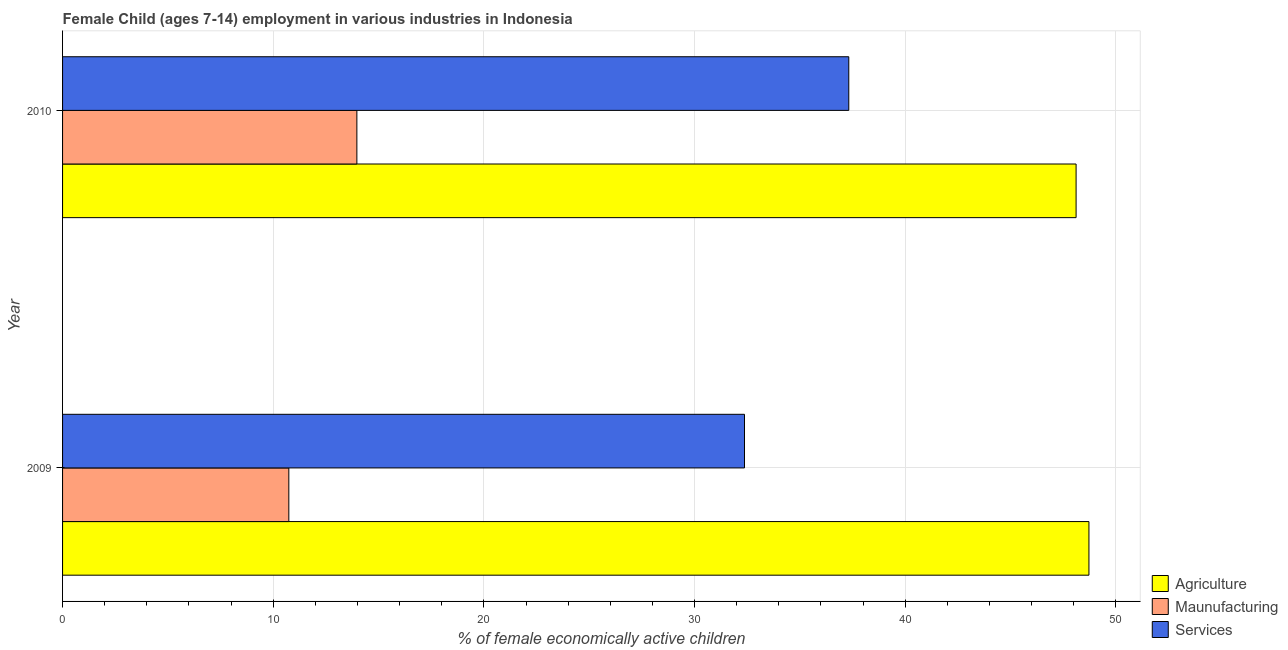How many groups of bars are there?
Offer a very short reply. 2. Are the number of bars per tick equal to the number of legend labels?
Make the answer very short. Yes. Are the number of bars on each tick of the Y-axis equal?
Your answer should be very brief. Yes. How many bars are there on the 2nd tick from the top?
Provide a succinct answer. 3. How many bars are there on the 1st tick from the bottom?
Ensure brevity in your answer.  3. What is the label of the 2nd group of bars from the top?
Your response must be concise. 2009. What is the percentage of economically active children in agriculture in 2009?
Make the answer very short. 48.72. Across all years, what is the maximum percentage of economically active children in manufacturing?
Your answer should be compact. 13.97. Across all years, what is the minimum percentage of economically active children in agriculture?
Your answer should be compact. 48.11. In which year was the percentage of economically active children in agriculture maximum?
Offer a very short reply. 2009. What is the total percentage of economically active children in manufacturing in the graph?
Offer a terse response. 24.71. What is the difference between the percentage of economically active children in manufacturing in 2009 and that in 2010?
Ensure brevity in your answer.  -3.23. What is the difference between the percentage of economically active children in manufacturing in 2010 and the percentage of economically active children in services in 2009?
Ensure brevity in your answer.  -18.4. What is the average percentage of economically active children in services per year?
Offer a very short reply. 34.84. In the year 2010, what is the difference between the percentage of economically active children in services and percentage of economically active children in manufacturing?
Give a very brief answer. 23.35. What is the ratio of the percentage of economically active children in manufacturing in 2009 to that in 2010?
Keep it short and to the point. 0.77. Is the percentage of economically active children in services in 2009 less than that in 2010?
Keep it short and to the point. Yes. Is the difference between the percentage of economically active children in agriculture in 2009 and 2010 greater than the difference between the percentage of economically active children in manufacturing in 2009 and 2010?
Your answer should be compact. Yes. In how many years, is the percentage of economically active children in services greater than the average percentage of economically active children in services taken over all years?
Your response must be concise. 1. What does the 1st bar from the top in 2009 represents?
Provide a short and direct response. Services. What does the 2nd bar from the bottom in 2009 represents?
Offer a very short reply. Maunufacturing. How many bars are there?
Offer a very short reply. 6. Are all the bars in the graph horizontal?
Offer a terse response. Yes. How many years are there in the graph?
Offer a terse response. 2. Does the graph contain any zero values?
Your response must be concise. No. How are the legend labels stacked?
Ensure brevity in your answer.  Vertical. What is the title of the graph?
Make the answer very short. Female Child (ages 7-14) employment in various industries in Indonesia. Does "Infant(male)" appear as one of the legend labels in the graph?
Offer a very short reply. No. What is the label or title of the X-axis?
Your answer should be compact. % of female economically active children. What is the label or title of the Y-axis?
Make the answer very short. Year. What is the % of female economically active children of Agriculture in 2009?
Give a very brief answer. 48.72. What is the % of female economically active children in Maunufacturing in 2009?
Provide a succinct answer. 10.74. What is the % of female economically active children of Services in 2009?
Offer a terse response. 32.37. What is the % of female economically active children of Agriculture in 2010?
Make the answer very short. 48.11. What is the % of female economically active children in Maunufacturing in 2010?
Your answer should be very brief. 13.97. What is the % of female economically active children of Services in 2010?
Provide a short and direct response. 37.32. Across all years, what is the maximum % of female economically active children of Agriculture?
Provide a short and direct response. 48.72. Across all years, what is the maximum % of female economically active children of Maunufacturing?
Offer a very short reply. 13.97. Across all years, what is the maximum % of female economically active children of Services?
Make the answer very short. 37.32. Across all years, what is the minimum % of female economically active children of Agriculture?
Your answer should be compact. 48.11. Across all years, what is the minimum % of female economically active children of Maunufacturing?
Make the answer very short. 10.74. Across all years, what is the minimum % of female economically active children in Services?
Offer a terse response. 32.37. What is the total % of female economically active children in Agriculture in the graph?
Ensure brevity in your answer.  96.83. What is the total % of female economically active children in Maunufacturing in the graph?
Ensure brevity in your answer.  24.71. What is the total % of female economically active children in Services in the graph?
Keep it short and to the point. 69.69. What is the difference between the % of female economically active children of Agriculture in 2009 and that in 2010?
Give a very brief answer. 0.61. What is the difference between the % of female economically active children of Maunufacturing in 2009 and that in 2010?
Ensure brevity in your answer.  -3.23. What is the difference between the % of female economically active children in Services in 2009 and that in 2010?
Provide a succinct answer. -4.95. What is the difference between the % of female economically active children of Agriculture in 2009 and the % of female economically active children of Maunufacturing in 2010?
Ensure brevity in your answer.  34.75. What is the difference between the % of female economically active children in Maunufacturing in 2009 and the % of female economically active children in Services in 2010?
Give a very brief answer. -26.58. What is the average % of female economically active children of Agriculture per year?
Your answer should be compact. 48.41. What is the average % of female economically active children in Maunufacturing per year?
Your answer should be very brief. 12.36. What is the average % of female economically active children in Services per year?
Offer a terse response. 34.84. In the year 2009, what is the difference between the % of female economically active children of Agriculture and % of female economically active children of Maunufacturing?
Offer a terse response. 37.98. In the year 2009, what is the difference between the % of female economically active children in Agriculture and % of female economically active children in Services?
Keep it short and to the point. 16.35. In the year 2009, what is the difference between the % of female economically active children in Maunufacturing and % of female economically active children in Services?
Provide a succinct answer. -21.63. In the year 2010, what is the difference between the % of female economically active children in Agriculture and % of female economically active children in Maunufacturing?
Provide a succinct answer. 34.14. In the year 2010, what is the difference between the % of female economically active children of Agriculture and % of female economically active children of Services?
Provide a succinct answer. 10.79. In the year 2010, what is the difference between the % of female economically active children in Maunufacturing and % of female economically active children in Services?
Keep it short and to the point. -23.35. What is the ratio of the % of female economically active children in Agriculture in 2009 to that in 2010?
Your answer should be very brief. 1.01. What is the ratio of the % of female economically active children of Maunufacturing in 2009 to that in 2010?
Provide a succinct answer. 0.77. What is the ratio of the % of female economically active children of Services in 2009 to that in 2010?
Your answer should be very brief. 0.87. What is the difference between the highest and the second highest % of female economically active children in Agriculture?
Offer a very short reply. 0.61. What is the difference between the highest and the second highest % of female economically active children of Maunufacturing?
Give a very brief answer. 3.23. What is the difference between the highest and the second highest % of female economically active children in Services?
Offer a terse response. 4.95. What is the difference between the highest and the lowest % of female economically active children of Agriculture?
Provide a short and direct response. 0.61. What is the difference between the highest and the lowest % of female economically active children in Maunufacturing?
Your response must be concise. 3.23. What is the difference between the highest and the lowest % of female economically active children of Services?
Give a very brief answer. 4.95. 